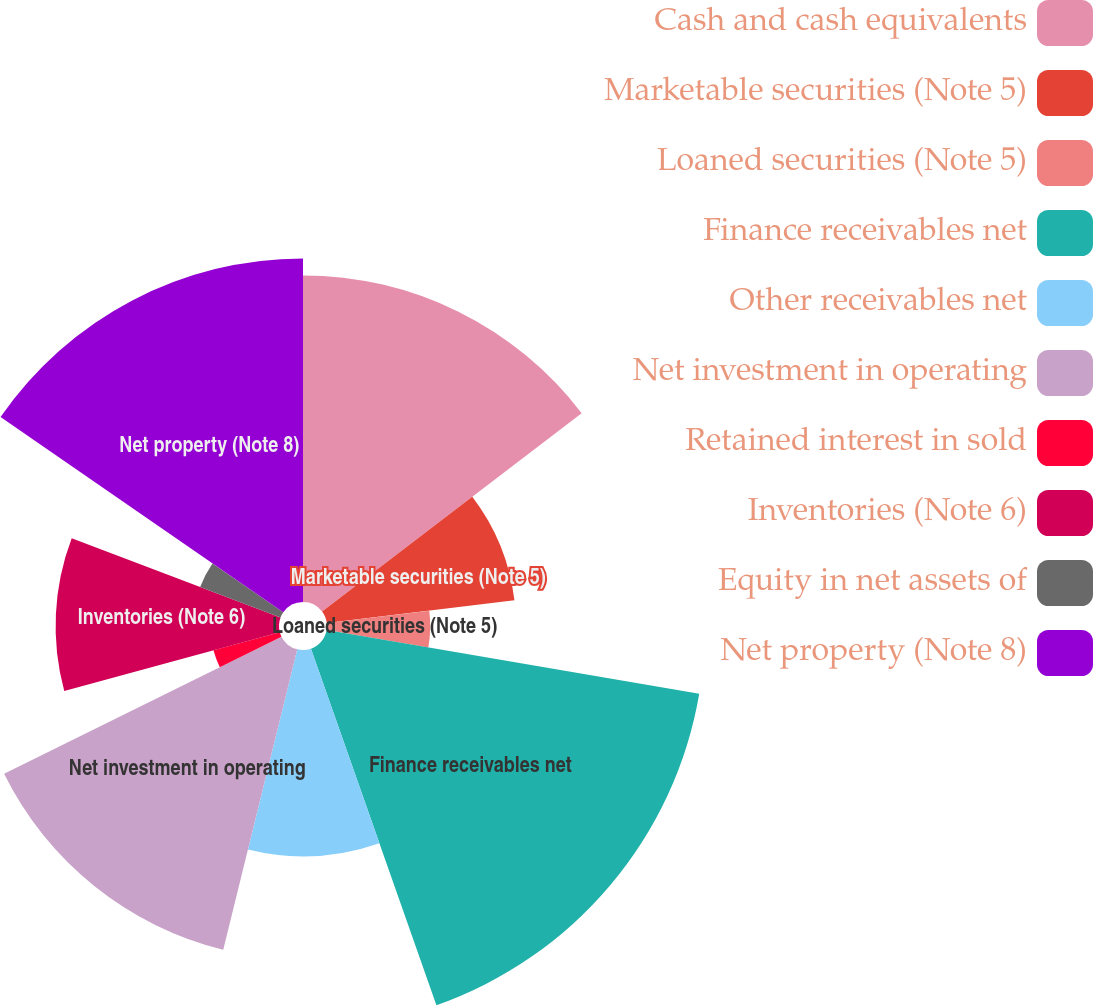Convert chart. <chart><loc_0><loc_0><loc_500><loc_500><pie_chart><fcel>Cash and cash equivalents<fcel>Marketable securities (Note 5)<fcel>Loaned securities (Note 5)<fcel>Finance receivables net<fcel>Other receivables net<fcel>Net investment in operating<fcel>Retained interest in sold<fcel>Inventories (Note 6)<fcel>Equity in net assets of<fcel>Net property (Note 8)<nl><fcel>14.62%<fcel>8.46%<fcel>4.62%<fcel>16.92%<fcel>9.23%<fcel>13.85%<fcel>3.08%<fcel>10.0%<fcel>3.85%<fcel>15.38%<nl></chart> 